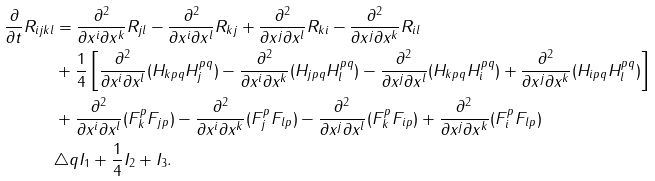Convert formula to latex. <formula><loc_0><loc_0><loc_500><loc_500>\frac { \partial } { \partial t } R _ { i j k l } & = \frac { \partial ^ { 2 } } { \partial x ^ { i } \partial x ^ { k } } R _ { j l } - \frac { \partial ^ { 2 } } { \partial x ^ { i } \partial x ^ { l } } R _ { k j } + \frac { \partial ^ { 2 } } { \partial x ^ { j } \partial x ^ { l } } R _ { k i } - \frac { \partial ^ { 2 } } { \partial x ^ { j } \partial x ^ { k } } R _ { i l } \\ & + \frac { 1 } { 4 } \left [ \frac { \partial ^ { 2 } } { \partial x ^ { i } \partial x ^ { l } } ( H _ { k p q } H _ { j } ^ { p q } ) - \frac { \partial ^ { 2 } } { \partial x ^ { i } \partial x ^ { k } } ( H _ { j p q } H _ { l } ^ { p q } ) - \frac { \partial ^ { 2 } } { \partial x ^ { j } \partial x ^ { l } } ( H _ { k p q } H _ { i } ^ { p q } ) + \frac { \partial ^ { 2 } } { \partial x ^ { j } \partial x ^ { k } } ( H _ { i p q } H _ { l } ^ { p q } ) \right ] \\ & + \frac { \partial ^ { 2 } } { \partial x ^ { i } \partial x ^ { l } } ( F _ { k } ^ { p } F _ { j p } ) - \frac { \partial ^ { 2 } } { \partial x ^ { i } \partial x ^ { k } } ( F _ { j } ^ { p } F _ { l p } ) - \frac { \partial ^ { 2 } } { \partial x ^ { j } \partial x ^ { l } } ( F _ { k } ^ { p } F _ { i p } ) + \frac { \partial ^ { 2 } } { \partial x ^ { j } \partial x ^ { k } } ( F _ { i } ^ { p } F _ { l p } ) \\ & \triangle q I _ { 1 } + \frac { 1 } { 4 } I _ { 2 } + I _ { 3 } .</formula> 